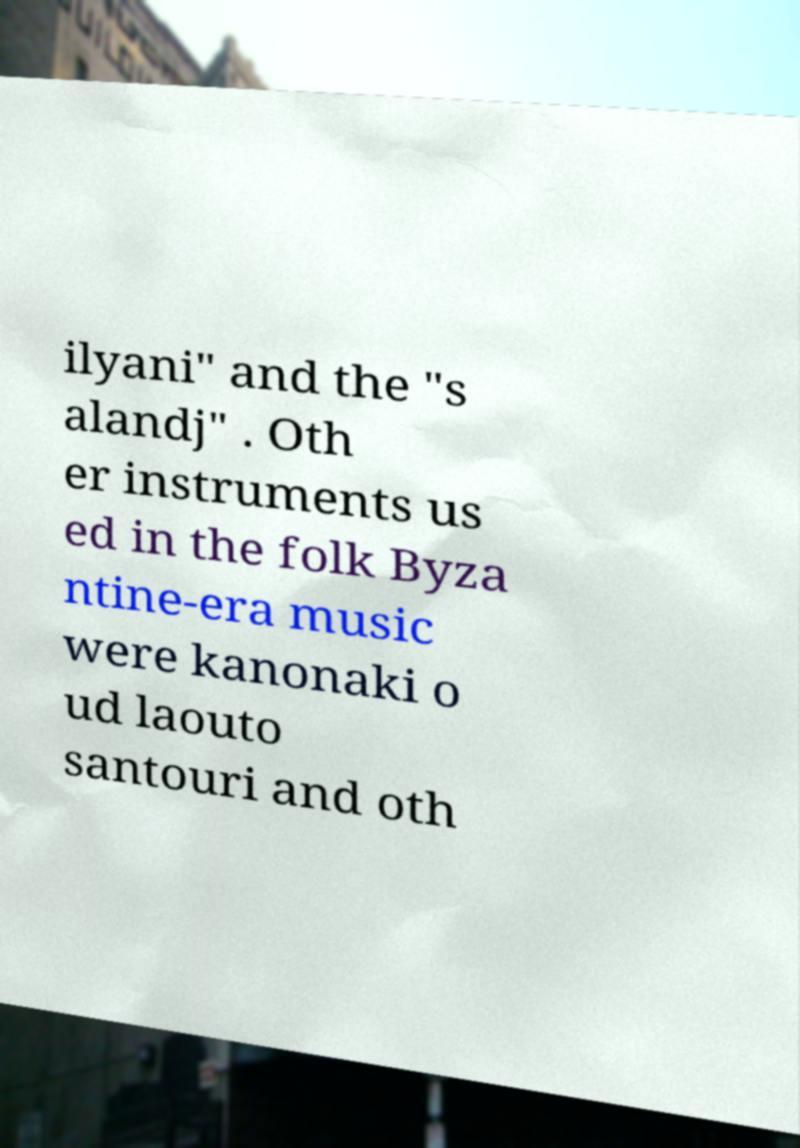For documentation purposes, I need the text within this image transcribed. Could you provide that? ilyani" and the "s alandj" . Oth er instruments us ed in the folk Byza ntine-era music were kanonaki o ud laouto santouri and oth 